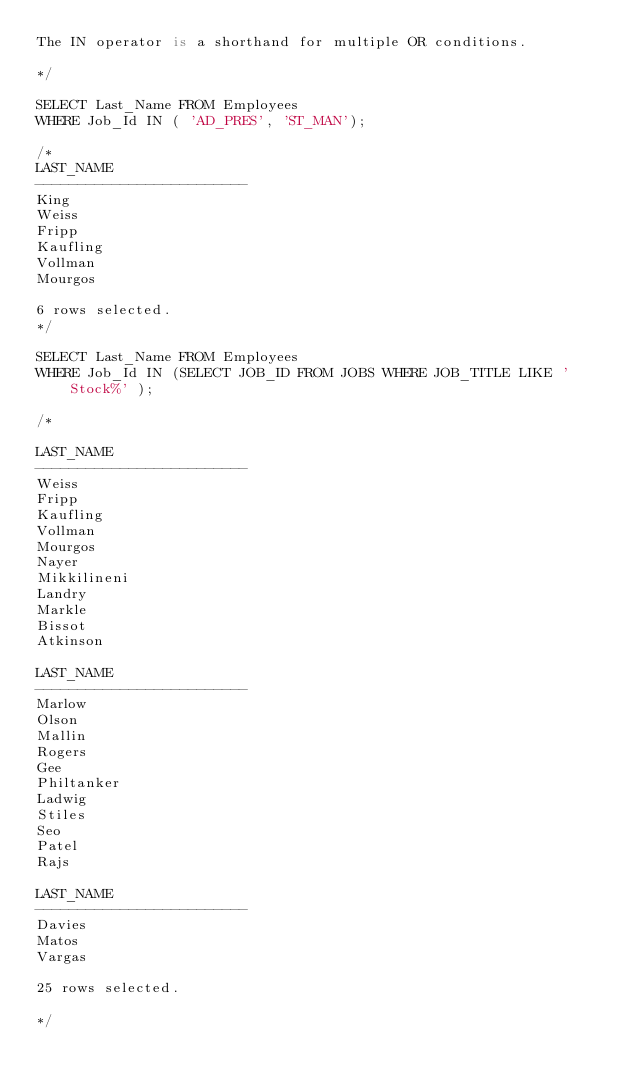<code> <loc_0><loc_0><loc_500><loc_500><_SQL_>The IN operator is a shorthand for multiple OR conditions.

*/

SELECT Last_Name FROM Employees
WHERE Job_Id IN ( 'AD_PRES', 'ST_MAN');

/*
LAST_NAME                
-------------------------
King
Weiss
Fripp
Kaufling
Vollman
Mourgos

6 rows selected. 
*/

SELECT Last_Name FROM Employees
WHERE Job_Id IN (SELECT JOB_ID FROM JOBS WHERE JOB_TITLE LIKE 'Stock%' );

/*

LAST_NAME                
-------------------------
Weiss
Fripp
Kaufling
Vollman
Mourgos
Nayer
Mikkilineni
Landry
Markle
Bissot
Atkinson

LAST_NAME                
-------------------------
Marlow
Olson
Mallin
Rogers
Gee
Philtanker
Ladwig
Stiles
Seo
Patel
Rajs

LAST_NAME                
-------------------------
Davies
Matos
Vargas

25 rows selected. 

*/
</code> 